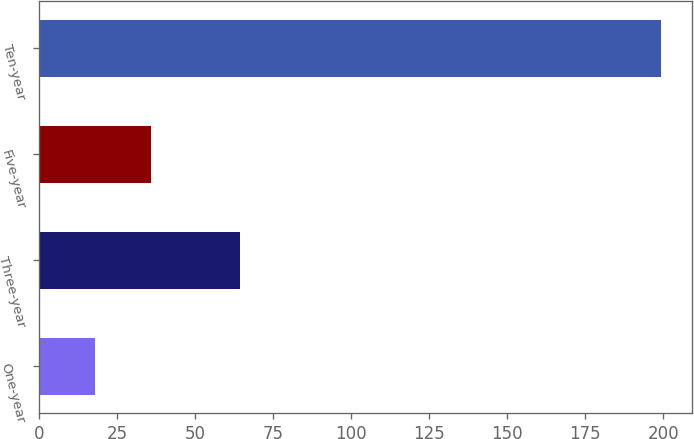Convert chart. <chart><loc_0><loc_0><loc_500><loc_500><bar_chart><fcel>One-year<fcel>Three-year<fcel>Five-year<fcel>Ten-year<nl><fcel>17.8<fcel>64.5<fcel>35.93<fcel>199.1<nl></chart> 